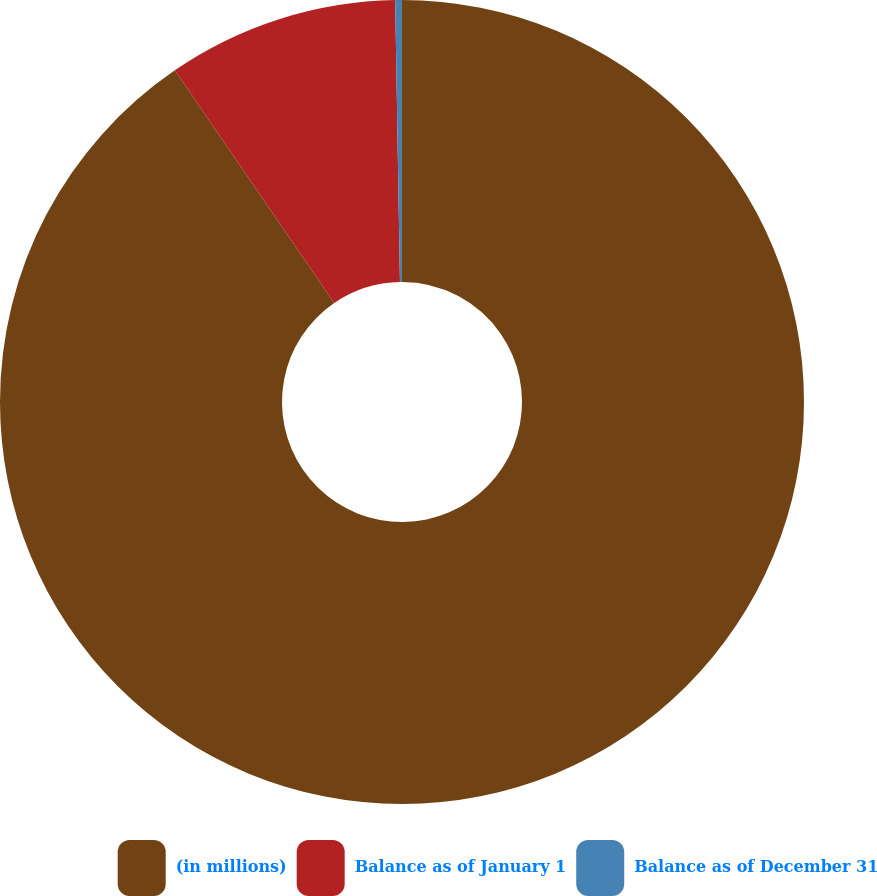Convert chart. <chart><loc_0><loc_0><loc_500><loc_500><pie_chart><fcel>(in millions)<fcel>Balance as of January 1<fcel>Balance as of December 31<nl><fcel>90.44%<fcel>9.29%<fcel>0.27%<nl></chart> 